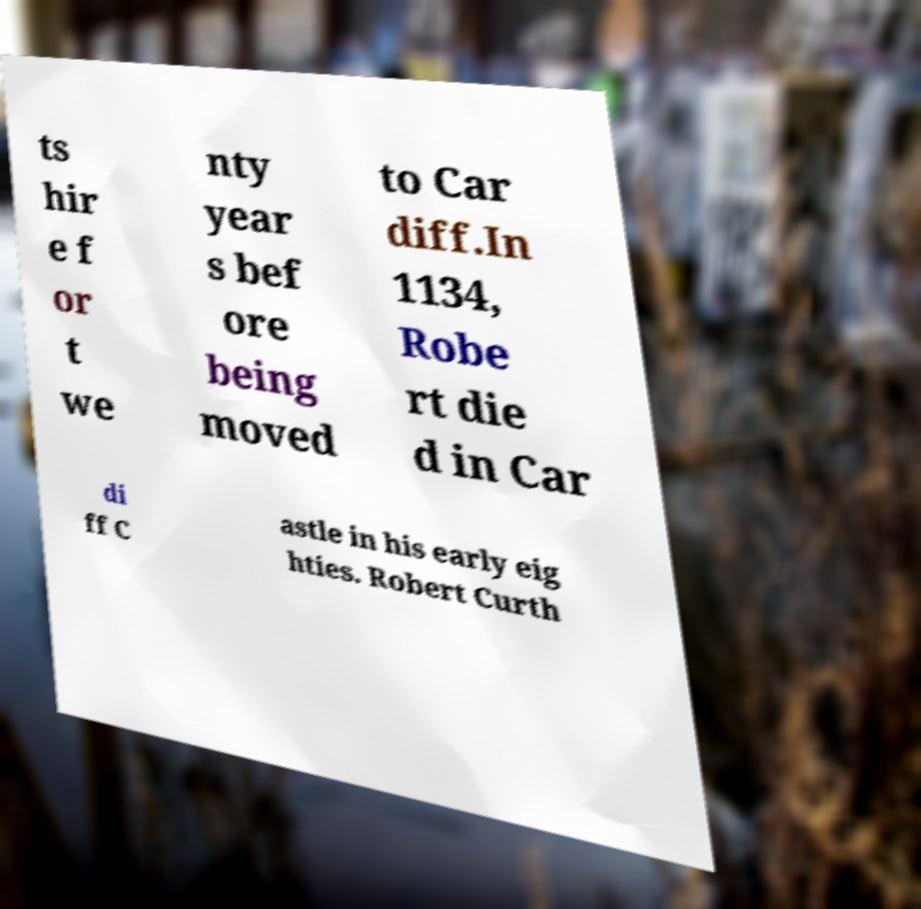Could you assist in decoding the text presented in this image and type it out clearly? ts hir e f or t we nty year s bef ore being moved to Car diff.In 1134, Robe rt die d in Car di ff C astle in his early eig hties. Robert Curth 